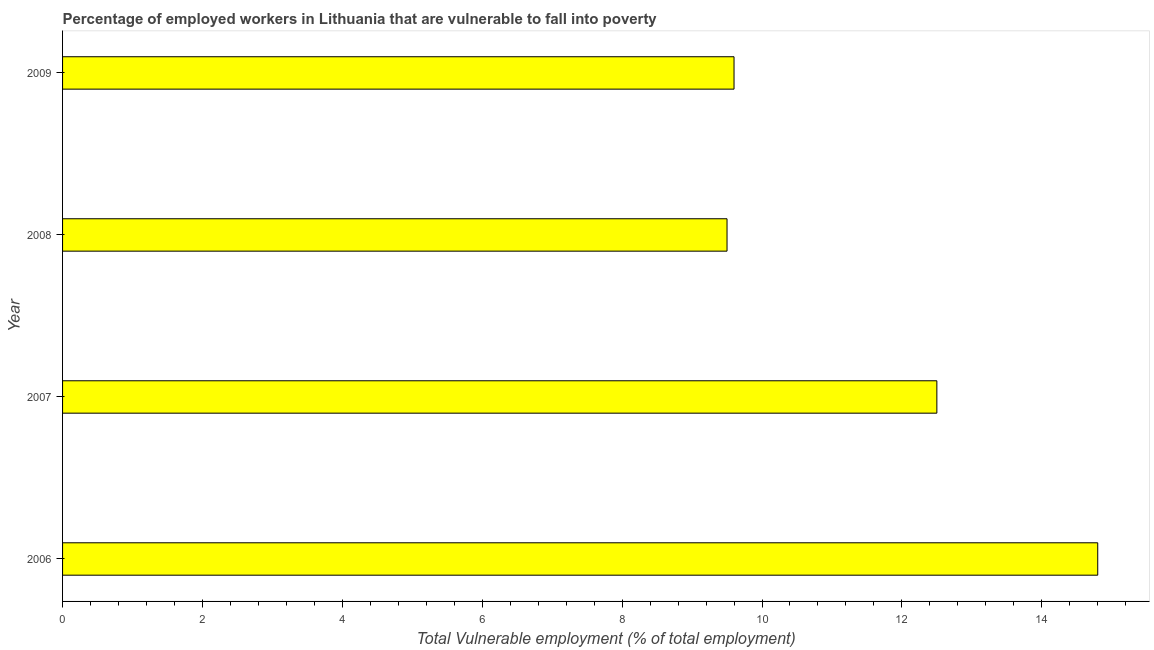Does the graph contain any zero values?
Provide a succinct answer. No. Does the graph contain grids?
Provide a succinct answer. No. What is the title of the graph?
Provide a short and direct response. Percentage of employed workers in Lithuania that are vulnerable to fall into poverty. What is the label or title of the X-axis?
Your answer should be compact. Total Vulnerable employment (% of total employment). What is the label or title of the Y-axis?
Provide a short and direct response. Year. Across all years, what is the maximum total vulnerable employment?
Provide a succinct answer. 14.8. In which year was the total vulnerable employment maximum?
Provide a short and direct response. 2006. What is the sum of the total vulnerable employment?
Ensure brevity in your answer.  46.4. What is the average total vulnerable employment per year?
Make the answer very short. 11.6. What is the median total vulnerable employment?
Ensure brevity in your answer.  11.05. Do a majority of the years between 2009 and 2007 (inclusive) have total vulnerable employment greater than 0.8 %?
Offer a very short reply. Yes. Is the difference between the total vulnerable employment in 2007 and 2008 greater than the difference between any two years?
Your answer should be compact. No. In how many years, is the total vulnerable employment greater than the average total vulnerable employment taken over all years?
Keep it short and to the point. 2. What is the difference between two consecutive major ticks on the X-axis?
Your response must be concise. 2. What is the Total Vulnerable employment (% of total employment) in 2006?
Provide a short and direct response. 14.8. What is the Total Vulnerable employment (% of total employment) in 2007?
Give a very brief answer. 12.5. What is the Total Vulnerable employment (% of total employment) of 2009?
Offer a very short reply. 9.6. What is the difference between the Total Vulnerable employment (% of total employment) in 2006 and 2007?
Offer a very short reply. 2.3. What is the difference between the Total Vulnerable employment (% of total employment) in 2006 and 2008?
Ensure brevity in your answer.  5.3. What is the difference between the Total Vulnerable employment (% of total employment) in 2006 and 2009?
Provide a short and direct response. 5.2. What is the difference between the Total Vulnerable employment (% of total employment) in 2007 and 2008?
Keep it short and to the point. 3. What is the difference between the Total Vulnerable employment (% of total employment) in 2007 and 2009?
Give a very brief answer. 2.9. What is the ratio of the Total Vulnerable employment (% of total employment) in 2006 to that in 2007?
Your response must be concise. 1.18. What is the ratio of the Total Vulnerable employment (% of total employment) in 2006 to that in 2008?
Your answer should be very brief. 1.56. What is the ratio of the Total Vulnerable employment (% of total employment) in 2006 to that in 2009?
Your response must be concise. 1.54. What is the ratio of the Total Vulnerable employment (% of total employment) in 2007 to that in 2008?
Offer a terse response. 1.32. What is the ratio of the Total Vulnerable employment (% of total employment) in 2007 to that in 2009?
Your answer should be compact. 1.3. What is the ratio of the Total Vulnerable employment (% of total employment) in 2008 to that in 2009?
Ensure brevity in your answer.  0.99. 